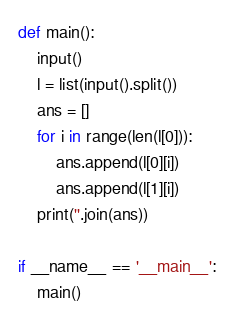Convert code to text. <code><loc_0><loc_0><loc_500><loc_500><_Python_>def main():
    input()
    l = list(input().split())
    ans = []
    for i in range(len(l[0])):
        ans.append(l[0][i])
        ans.append(l[1][i])
    print(''.join(ans))

if __name__ == '__main__':
    main()
</code> 